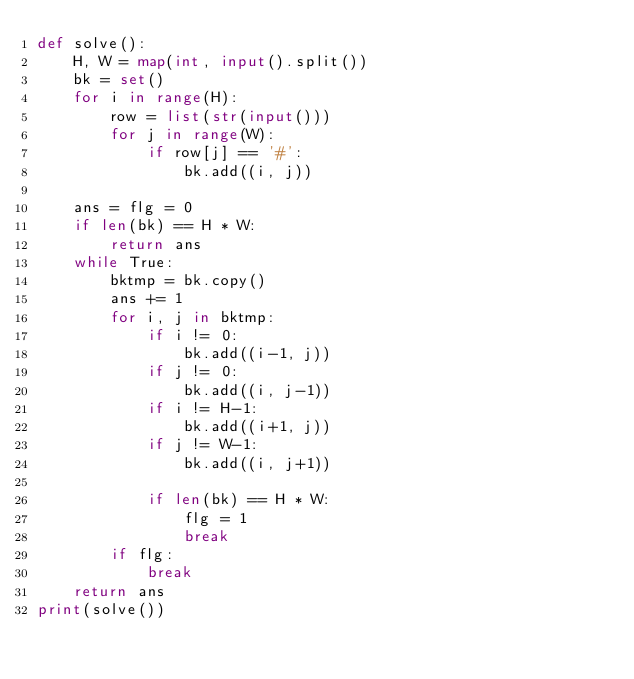<code> <loc_0><loc_0><loc_500><loc_500><_Python_>def solve():
    H, W = map(int, input().split())
    bk = set()
    for i in range(H):
        row = list(str(input()))
        for j in range(W):
            if row[j] == '#':
                bk.add((i, j))

    ans = flg = 0
    if len(bk) == H * W:
        return ans
    while True:
        bktmp = bk.copy()
        ans += 1
        for i, j in bktmp:
            if i != 0:
                bk.add((i-1, j))
            if j != 0:
                bk.add((i, j-1))
            if i != H-1:
                bk.add((i+1, j))
            if j != W-1:
                bk.add((i, j+1))

            if len(bk) == H * W:
                flg = 1
                break
        if flg:
            break
    return ans
print(solve())</code> 